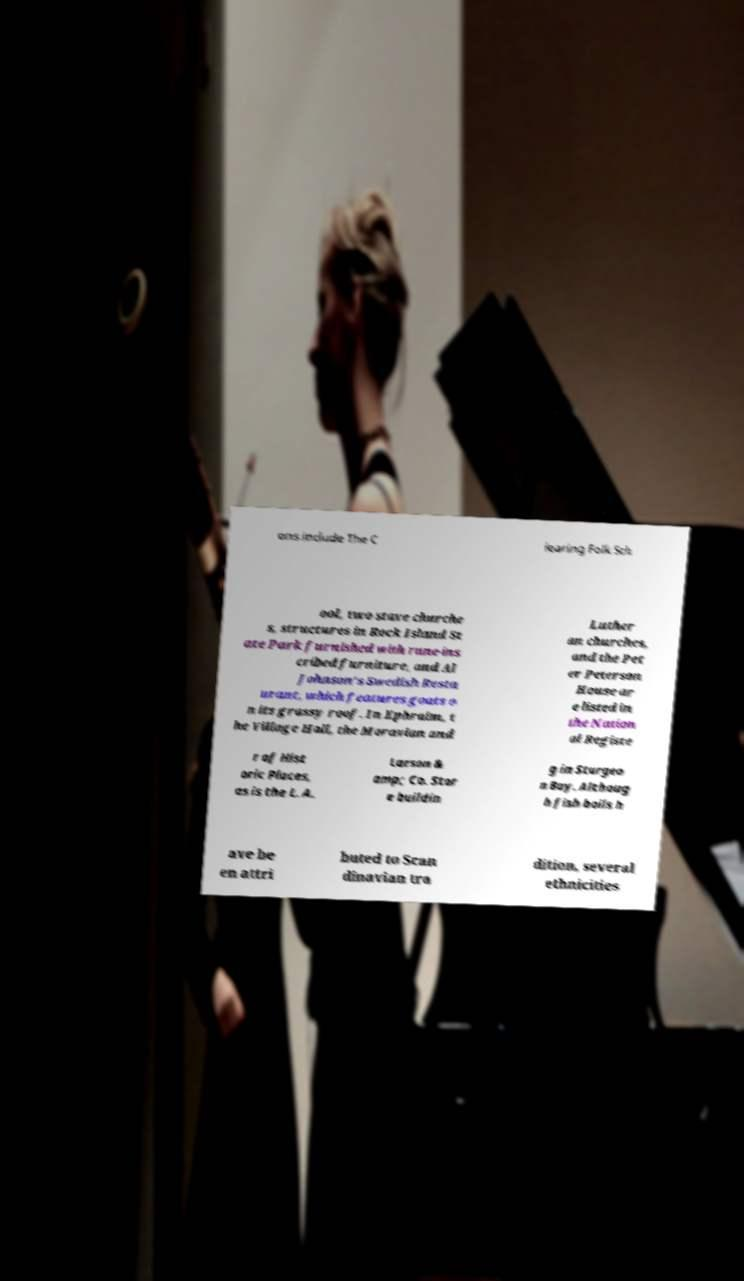Can you accurately transcribe the text from the provided image for me? ons include The C learing Folk Sch ool, two stave churche s, structures in Rock Island St ate Park furnished with rune-ins cribed furniture, and Al Johnson's Swedish Resta urant, which features goats o n its grassy roof. In Ephraim, t he Village Hall, the Moravian and Luther an churches, and the Pet er Peterson House ar e listed in the Nation al Registe r of Hist oric Places, as is the L. A. Larson & amp; Co. Stor e buildin g in Sturgeo n Bay. Althoug h fish boils h ave be en attri buted to Scan dinavian tra dition, several ethnicities 